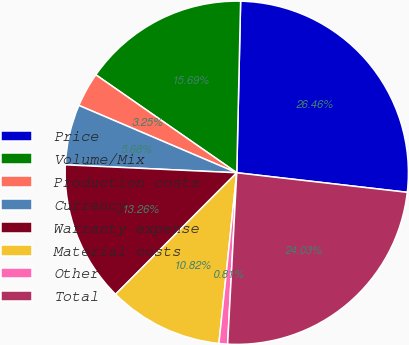<chart> <loc_0><loc_0><loc_500><loc_500><pie_chart><fcel>Price<fcel>Volume/Mix<fcel>Production costs<fcel>Currency<fcel>Warranty expense<fcel>Material costs<fcel>Other<fcel>Total<nl><fcel>26.46%<fcel>15.69%<fcel>3.25%<fcel>5.68%<fcel>13.26%<fcel>10.82%<fcel>0.81%<fcel>24.03%<nl></chart> 